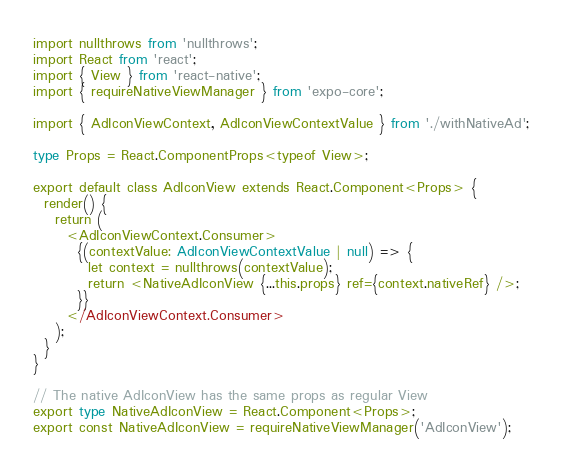Convert code to text. <code><loc_0><loc_0><loc_500><loc_500><_TypeScript_>import nullthrows from 'nullthrows';
import React from 'react';
import { View } from 'react-native';
import { requireNativeViewManager } from 'expo-core';

import { AdIconViewContext, AdIconViewContextValue } from './withNativeAd';

type Props = React.ComponentProps<typeof View>;

export default class AdIconView extends React.Component<Props> {
  render() {
    return (
      <AdIconViewContext.Consumer>
        {(contextValue: AdIconViewContextValue | null) => {
          let context = nullthrows(contextValue);
          return <NativeAdIconView {...this.props} ref={context.nativeRef} />;
        }}
      </AdIconViewContext.Consumer>
    );
  }
}

// The native AdIconView has the same props as regular View
export type NativeAdIconView = React.Component<Props>;
export const NativeAdIconView = requireNativeViewManager('AdIconView');
</code> 